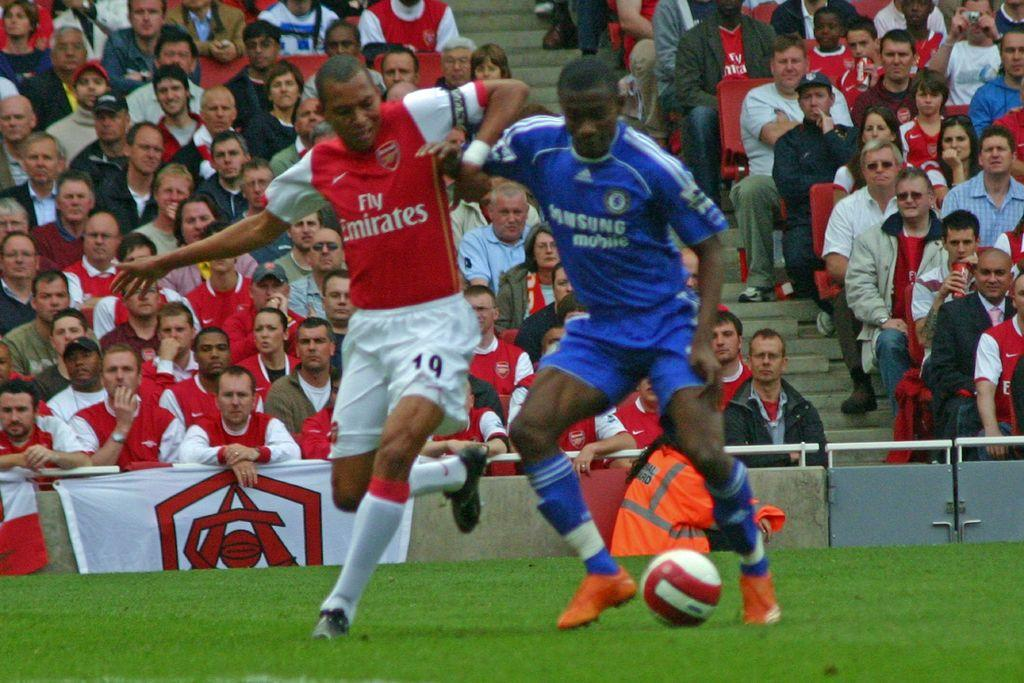Provide a one-sentence caption for the provided image. Two soccer players in a stadium with the one wearing the red jersey being number 19. 